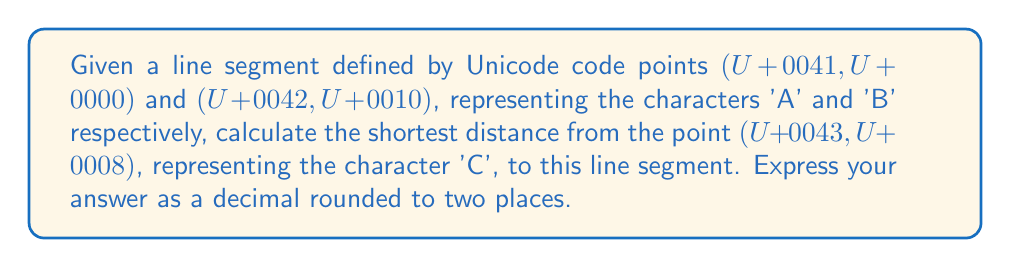What is the answer to this math problem? Let's approach this step-by-step:

1) First, we need to convert the Unicode code points to numerical coordinates:
   A: (U+0041, U+0000) → (65, 0)
   B: (U+0042, U+0010) → (66, 16)
   C: (U+0043, U+0008) → (67, 8)

2) Now we have a line segment from (65, 0) to (66, 16) and a point at (67, 8).

3) To find the shortest distance, we need to determine if the perpendicular from C to AB intersects AB. If it does, that's the shortest distance. If not, the shortest distance is to either A or B.

4) The vector from A to B is:
   $$\vec{AB} = (66-65, 16-0) = (1, 16)$$

5) The vector from A to C is:
   $$\vec{AC} = (67-65, 8-0) = (2, 8)$$

6) We can use the dot product to find the projection of AC onto AB:
   $$t = \frac{\vec{AC} \cdot \vec{AB}}{\|\vec{AB}\|^2} = \frac{2(1) + 8(16)}{1^2 + 16^2} = \frac{130}{257} \approx 0.506$$

7) Since 0 < t < 1, the perpendicular from C intersects AB.

8) The point of intersection P can be found:
   $$P = A + t\vec{AB} = (65, 0) + 0.506(1, 16) = (65.506, 8.096)$$

9) Now we can calculate the distance from C to P:
   $$d = \sqrt{(67-65.506)^2 + (8-8.096)^2} \approx 1.4959$$
Answer: $1.50$ 